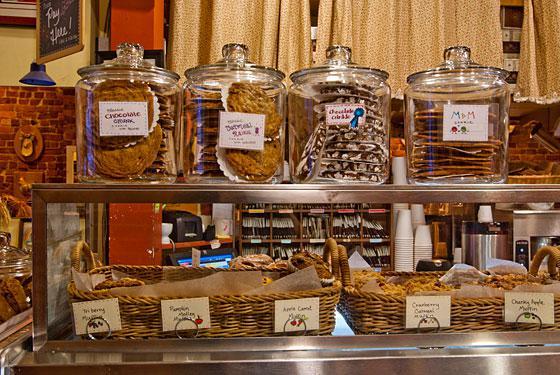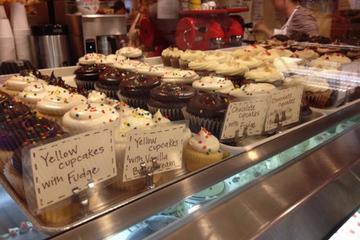The first image is the image on the left, the second image is the image on the right. Assess this claim about the two images: "A row of clear lidded canisters holding baked treats is on a chrome-edged shelf in a bakery.". Correct or not? Answer yes or no. Yes. The first image is the image on the left, the second image is the image on the right. For the images displayed, is the sentence "Three rows of iced cakes are arranged in a bakery on a bottom metal rack and two upper white wire racks, with larger round cakes on the two lower racks." factually correct? Answer yes or no. No. 